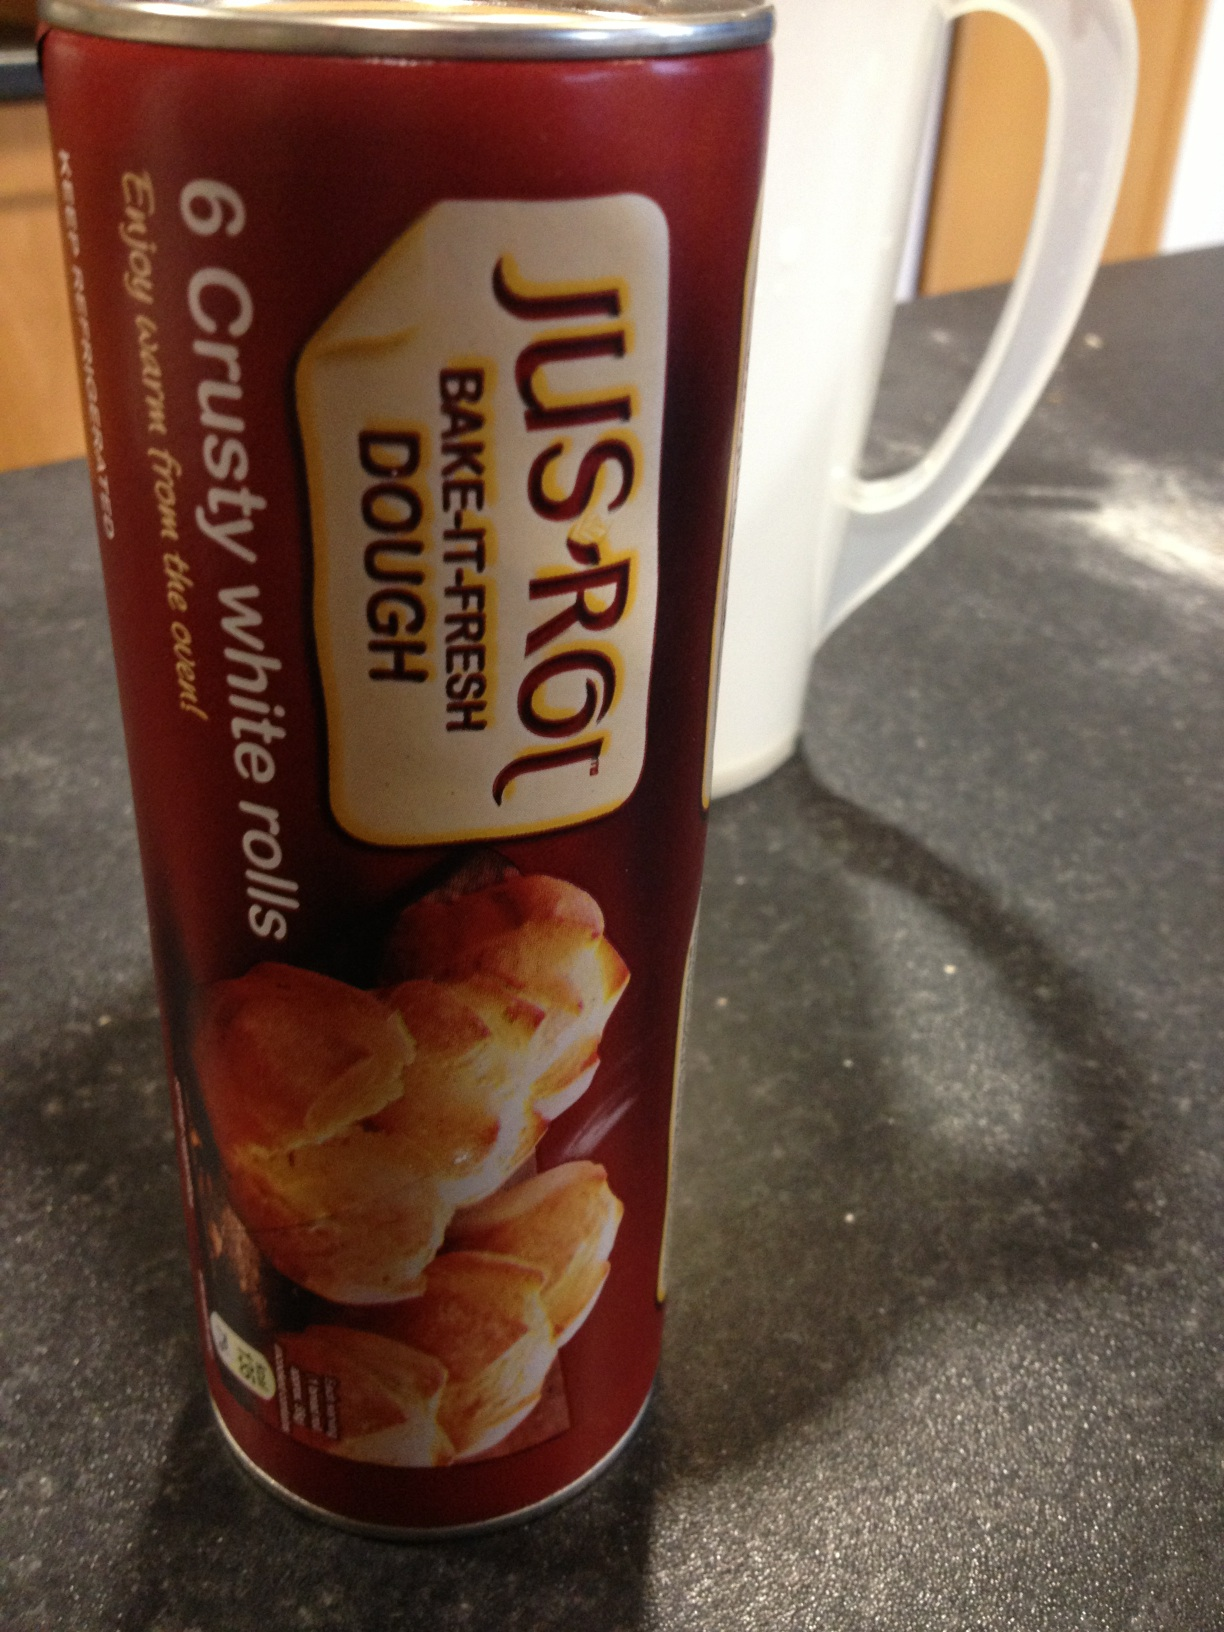If this product were to come alive, what kind of character would it be? If Jus-Rol Bake-It-Fresh Dough were to come alive, it would transform into a friendly, cheerful baker named Rollie! With a round, doughy appearance and a big smile, Rollie would bring warmth and joy to any kitchen. Always ready with a hearty laugh and a helpful tip, Rollie loves to share the love of baking with everyone, encouraging creativity and fun in the kitchen. A true embodiment of homey comfort and delicious aromas, Rollie inspires everyone to enjoy the simple pleasure of freshly baked rolls. 